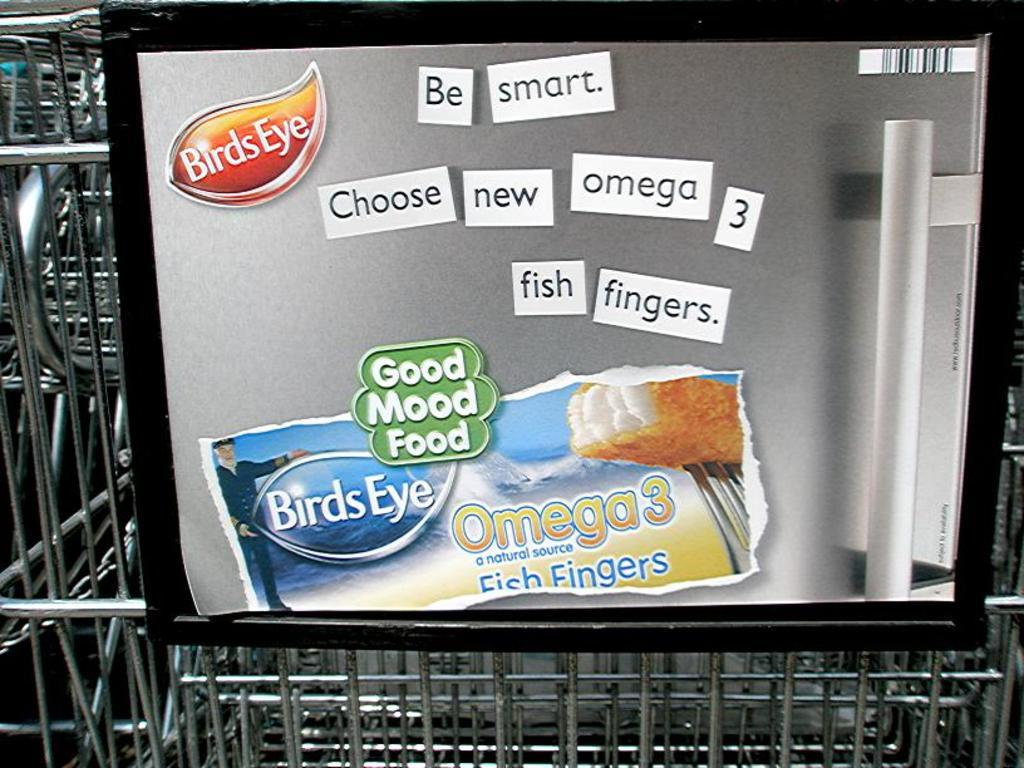<image>
Summarize the visual content of the image. Be smart and get your omega 3 by eating Bird's Eye fish fingers. 